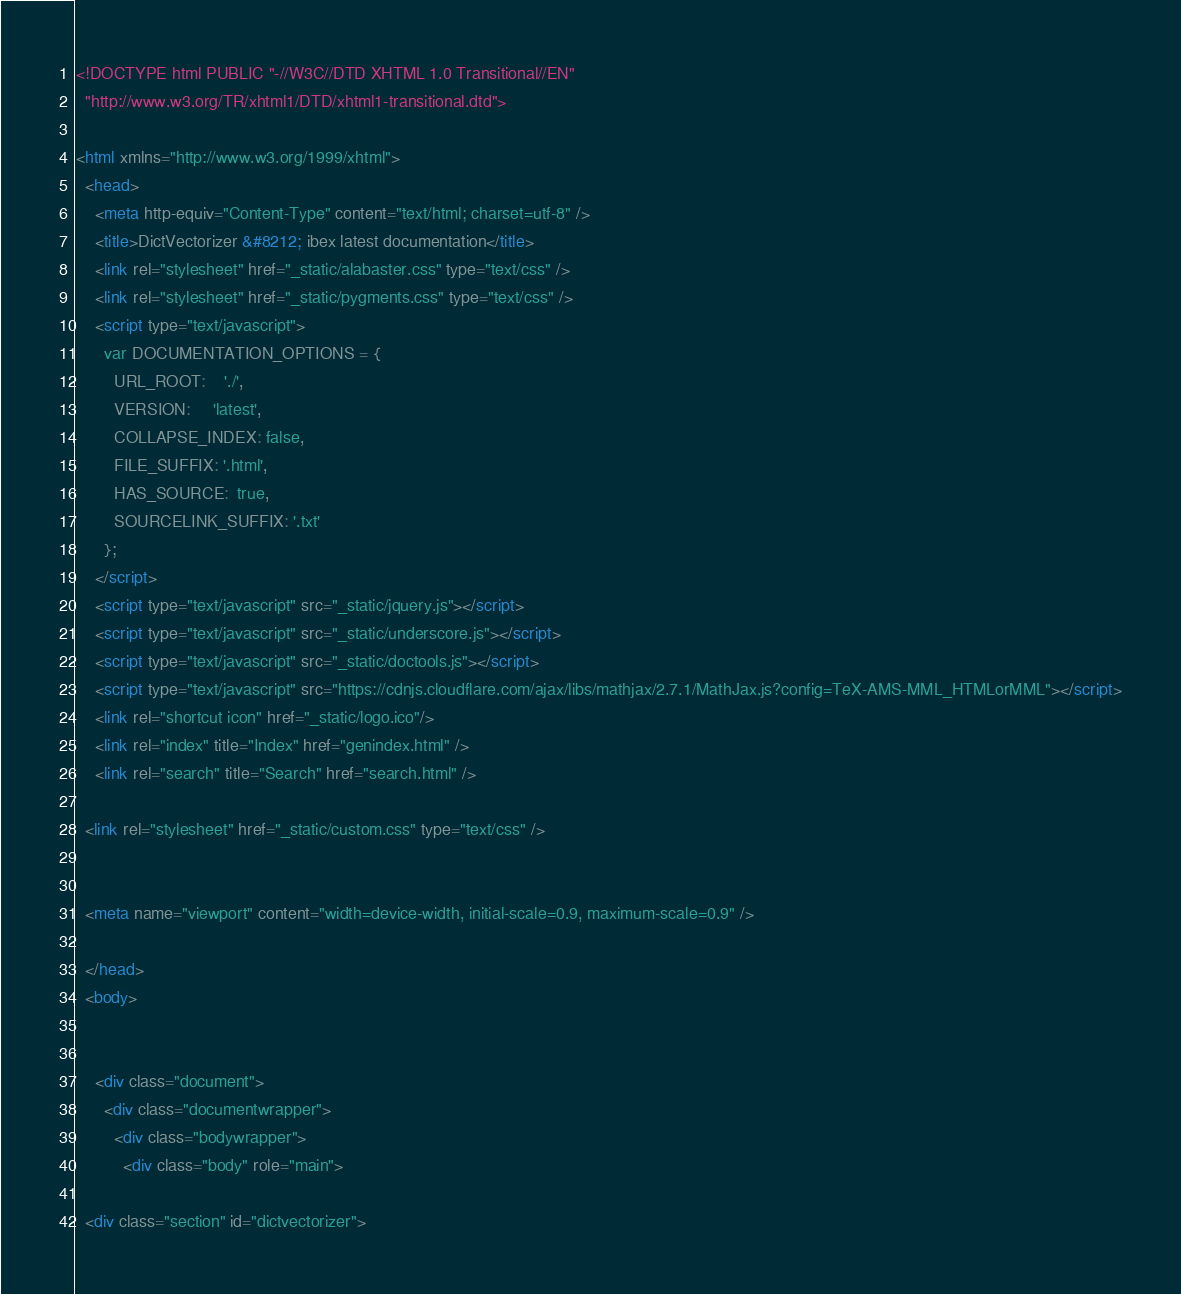Convert code to text. <code><loc_0><loc_0><loc_500><loc_500><_HTML_>
<!DOCTYPE html PUBLIC "-//W3C//DTD XHTML 1.0 Transitional//EN"
  "http://www.w3.org/TR/xhtml1/DTD/xhtml1-transitional.dtd">

<html xmlns="http://www.w3.org/1999/xhtml">
  <head>
    <meta http-equiv="Content-Type" content="text/html; charset=utf-8" />
    <title>DictVectorizer &#8212; ibex latest documentation</title>
    <link rel="stylesheet" href="_static/alabaster.css" type="text/css" />
    <link rel="stylesheet" href="_static/pygments.css" type="text/css" />
    <script type="text/javascript">
      var DOCUMENTATION_OPTIONS = {
        URL_ROOT:    './',
        VERSION:     'latest',
        COLLAPSE_INDEX: false,
        FILE_SUFFIX: '.html',
        HAS_SOURCE:  true,
        SOURCELINK_SUFFIX: '.txt'
      };
    </script>
    <script type="text/javascript" src="_static/jquery.js"></script>
    <script type="text/javascript" src="_static/underscore.js"></script>
    <script type="text/javascript" src="_static/doctools.js"></script>
    <script type="text/javascript" src="https://cdnjs.cloudflare.com/ajax/libs/mathjax/2.7.1/MathJax.js?config=TeX-AMS-MML_HTMLorMML"></script>
    <link rel="shortcut icon" href="_static/logo.ico"/>
    <link rel="index" title="Index" href="genindex.html" />
    <link rel="search" title="Search" href="search.html" />
   
  <link rel="stylesheet" href="_static/custom.css" type="text/css" />
  
  
  <meta name="viewport" content="width=device-width, initial-scale=0.9, maximum-scale=0.9" />

  </head>
  <body>
  

    <div class="document">
      <div class="documentwrapper">
        <div class="bodywrapper">
          <div class="body" role="main">
            
  <div class="section" id="dictvectorizer"></code> 